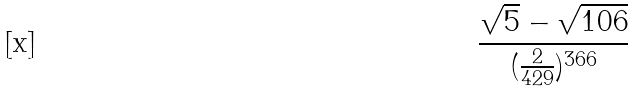<formula> <loc_0><loc_0><loc_500><loc_500>\frac { \sqrt { 5 } - \sqrt { 1 0 6 } } { ( \frac { 2 } { 4 2 9 } ) ^ { 3 6 6 } }</formula> 